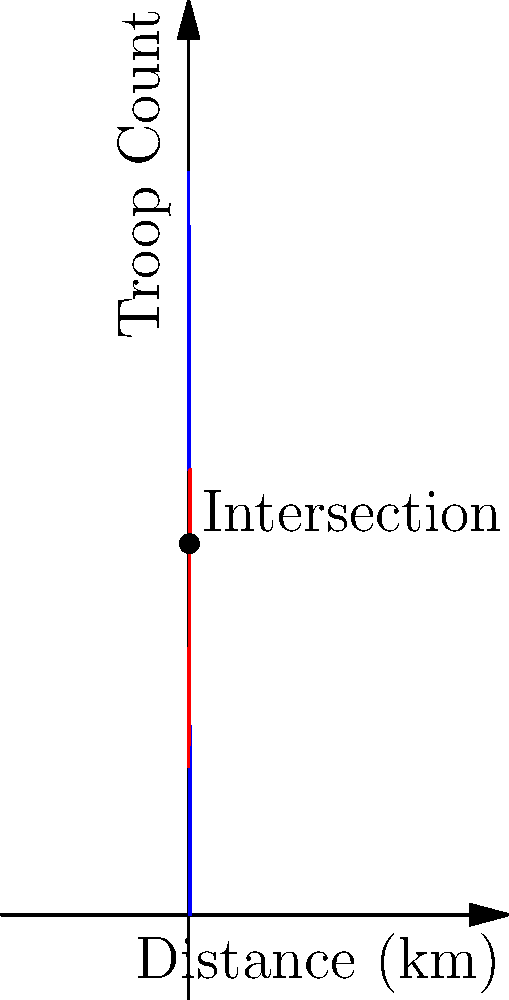Two opposing forces, A and B, are moving towards each other. Force A's troop count is given by the function $f(x) = 5000 - 500x$, where $x$ is the distance in kilometers from their starting point. Force B's troop count is given by $g(x) = 1000 + 200x$. At what distance do the forces have equal troop counts, and what is this count? Use calculus to solve this problem. To solve this problem, we need to find the intersection point of the two functions. This can be done by setting them equal to each other and solving for x.

1) Set the functions equal:
   $f(x) = g(x)$
   $5000 - 500x = 1000 + 200x$

2) Rearrange the equation:
   $5000 - 1000 = 200x + 500x$
   $4000 = 700x$

3) Solve for x:
   $x = 4000 / 700 = 5.714$ km

4) To find the troop count at this point, we can substitute this x-value into either function:
   $f(5.714) = 5000 - 500(5.714) = 2143$ troops

5) We can verify this with $g(x)$:
   $g(5.714) = 1000 + 200(5.714) = 2143$ troops

Therefore, the forces have equal troop counts at a distance of 5.714 km from Force A's starting point, and the troop count at this point is 2143.
Answer: Distance: 5.714 km; Troop count: 2143 